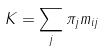Convert formula to latex. <formula><loc_0><loc_0><loc_500><loc_500>K = \sum _ { j } \pi _ { j } m _ { i j }</formula> 